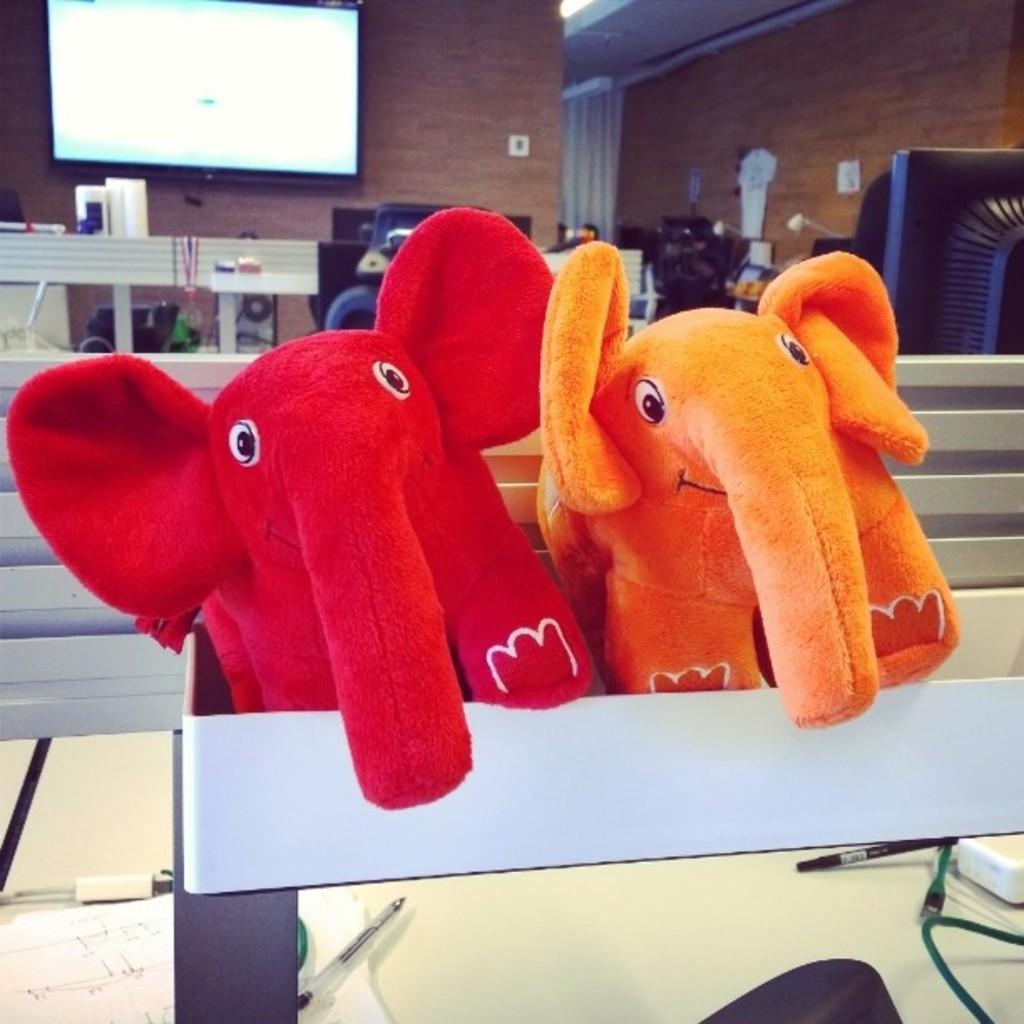Please provide a concise description of this image. As we can see in the image there are elephant toys, wall, benches, chairs and screen. 